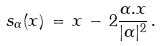<formula> <loc_0><loc_0><loc_500><loc_500>s _ { \alpha } ( x ) \, = \, x \, - \, 2 \frac { \alpha . x } { | \alpha | ^ { 2 } } \, .</formula> 